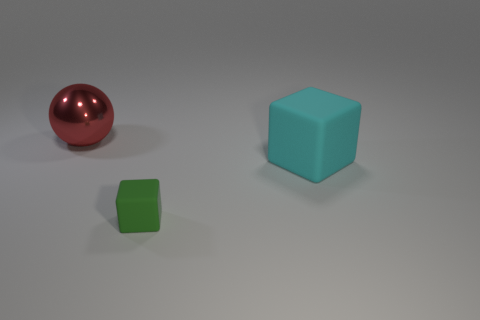There is a green thing that is the same material as the large cube; what size is it?
Your response must be concise. Small. What number of cyan things are small rubber objects or things?
Ensure brevity in your answer.  1. Is there anything else that has the same material as the large red object?
Your response must be concise. No. There is a large object right of the green thing; is its shape the same as the thing that is in front of the big cyan cube?
Offer a terse response. Yes. How many small gray shiny cylinders are there?
Keep it short and to the point. 0. Is there anything else of the same color as the shiny ball?
Keep it short and to the point. No. There is a small block; is its color the same as the rubber object to the right of the tiny green rubber cube?
Provide a succinct answer. No. Are there fewer large shiny spheres that are right of the large matte block than rubber things?
Your answer should be compact. Yes. There is a thing behind the large cyan rubber cube; what material is it?
Provide a succinct answer. Metal. What number of other things are there of the same size as the red object?
Your answer should be compact. 1. 